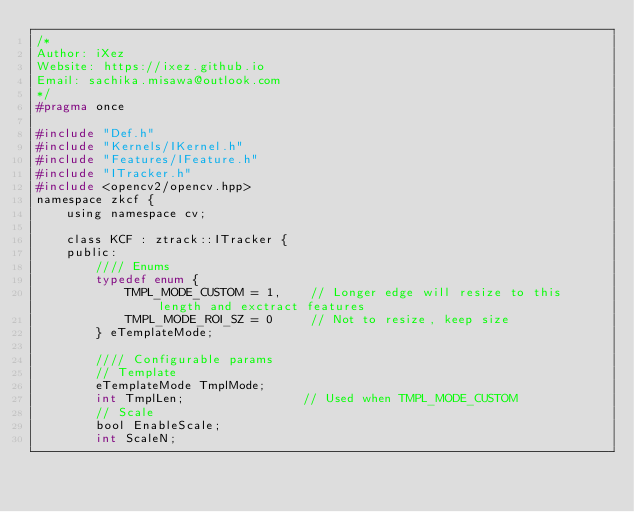Convert code to text. <code><loc_0><loc_0><loc_500><loc_500><_C_>/*
Author: iXez
Website: https://ixez.github.io
Email: sachika.misawa@outlook.com
*/
#pragma once

#include "Def.h"
#include "Kernels/IKernel.h"
#include "Features/IFeature.h"
#include "ITracker.h"
#include <opencv2/opencv.hpp>
namespace zkcf {
    using namespace cv;

    class KCF : ztrack::ITracker {
    public:
        //// Enums
        typedef enum {
            TMPL_MODE_CUSTOM = 1,    // Longer edge will resize to this length and exctract features
            TMPL_MODE_ROI_SZ = 0     // Not to resize, keep size
        } eTemplateMode;

        //// Configurable params
        // Template
        eTemplateMode TmplMode;
        int TmplLen;                // Used when TMPL_MODE_CUSTOM
        // Scale
        bool EnableScale;
        int ScaleN;</code> 